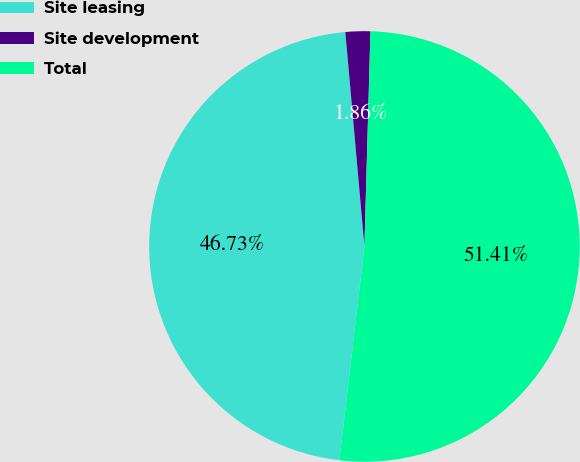Convert chart. <chart><loc_0><loc_0><loc_500><loc_500><pie_chart><fcel>Site leasing<fcel>Site development<fcel>Total<nl><fcel>46.73%<fcel>1.86%<fcel>51.41%<nl></chart> 